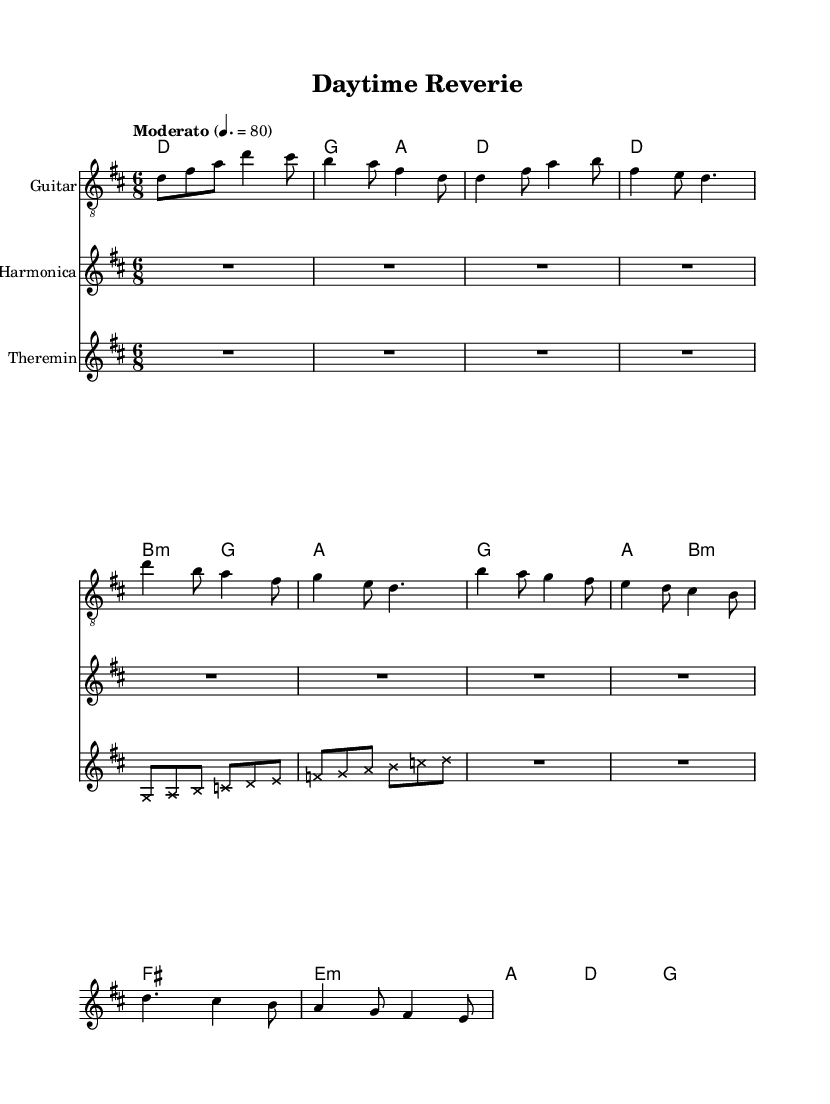What is the key signature of this music? The key signature identified in the music sheet is D major, which includes two sharps (F# and C#). This can be inferred from the \key d \major command in the global section of the code.
Answer: D major What is the time signature of this music? The time signature indicated in the sheet music is 6/8, which is depicted by the \time 6/8 line in the global section of the code. This time signature means there are six eighth notes per measure.
Answer: 6/8 What is the tempo marking for this piece? The tempo marking "Moderato" is mentioned in the global section of the score alongside the numerical value of 80 beats per minute. This indicates the speed at which the piece should be played.
Answer: Moderato, 80 How many instruments are featured in this music? The score explicitly includes three instruments: Guitar, Harmonica, and Theremin. This is evident from the sections where each instrument is separately defined within the score structure.
Answer: Three What is the function of the Theremin in this piece? In this experimental folk music, the Theremin simulates TV static, as indicated by the note head style and the note patterns designed to fall within a specific range. This adds an electronic texture to the music, combining retro soundscapes with the live instruments.
Answer: Simulating TV static Which instrument plays the counter-melody during the bridge? The harmonica is noted to play a counter-melody during the bridge section. This is confirmed by observing the harmonica's part specifically written out following the indication of the bridge within the other instruments.
Answer: Harmonica What type of chords are used in the guitar section? The guitar section includes a variety of chords including major, minor, and suspended chords indicated within the \chordmode. The use of chords like d, g, and b:m suggests a combination of both major and minor tonalities.
Answer: Major and minor chords 